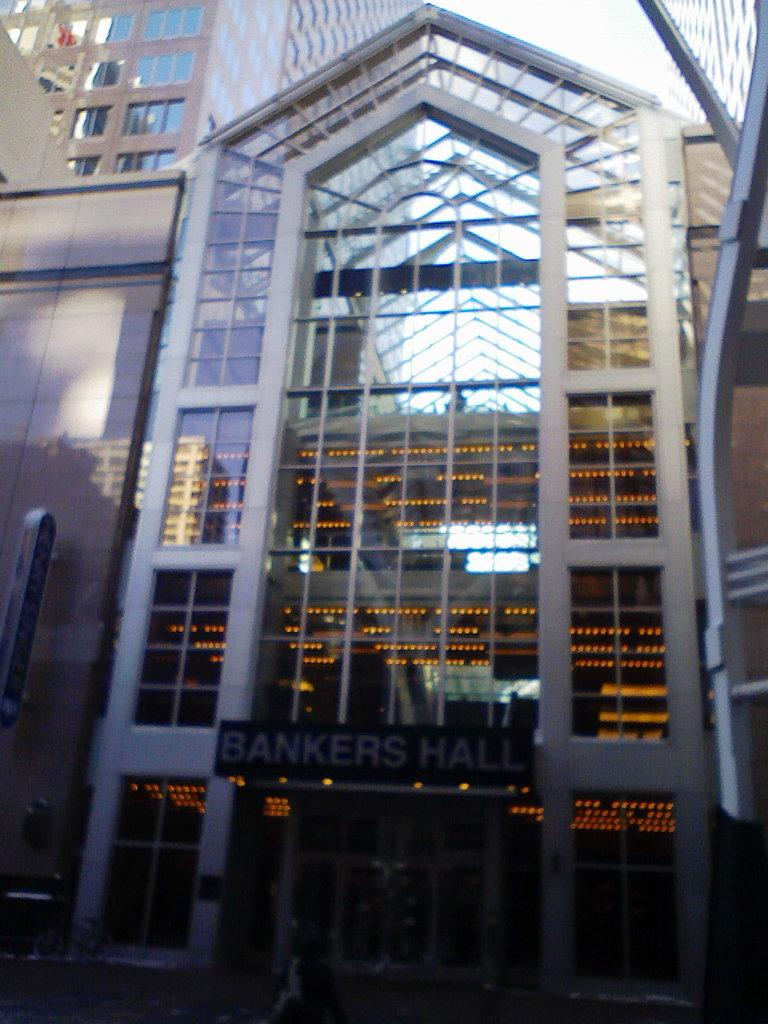What type of structures can be seen in the image? There are buildings in the image. What material is present in the image? Glass is present in the image. What can be seen illuminating the scene in the image? Lights are visible in the image. What separates the interior and exterior spaces in the image? Walls are present in the image. What is visible at the top of the image? The sky is visible at the top of the image. What signage is present in the image? There is a name board in the image. Can you tell me how many knees are visible in the image? There are no knees visible in the image. What type of journey is depicted in the image? There is no journey depicted in the image; it features buildings, glass, lights, walls, the sky, and a name board. 